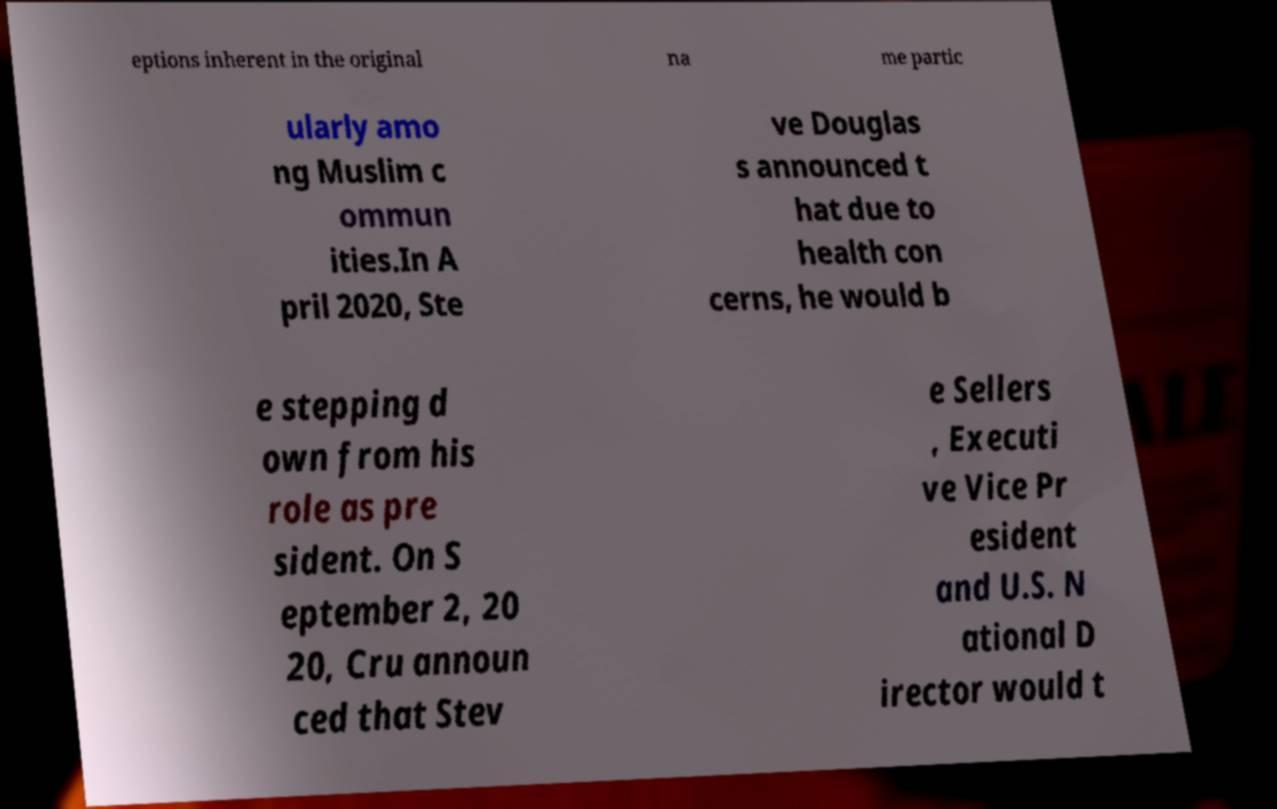I need the written content from this picture converted into text. Can you do that? eptions inherent in the original na me partic ularly amo ng Muslim c ommun ities.In A pril 2020, Ste ve Douglas s announced t hat due to health con cerns, he would b e stepping d own from his role as pre sident. On S eptember 2, 20 20, Cru announ ced that Stev e Sellers , Executi ve Vice Pr esident and U.S. N ational D irector would t 